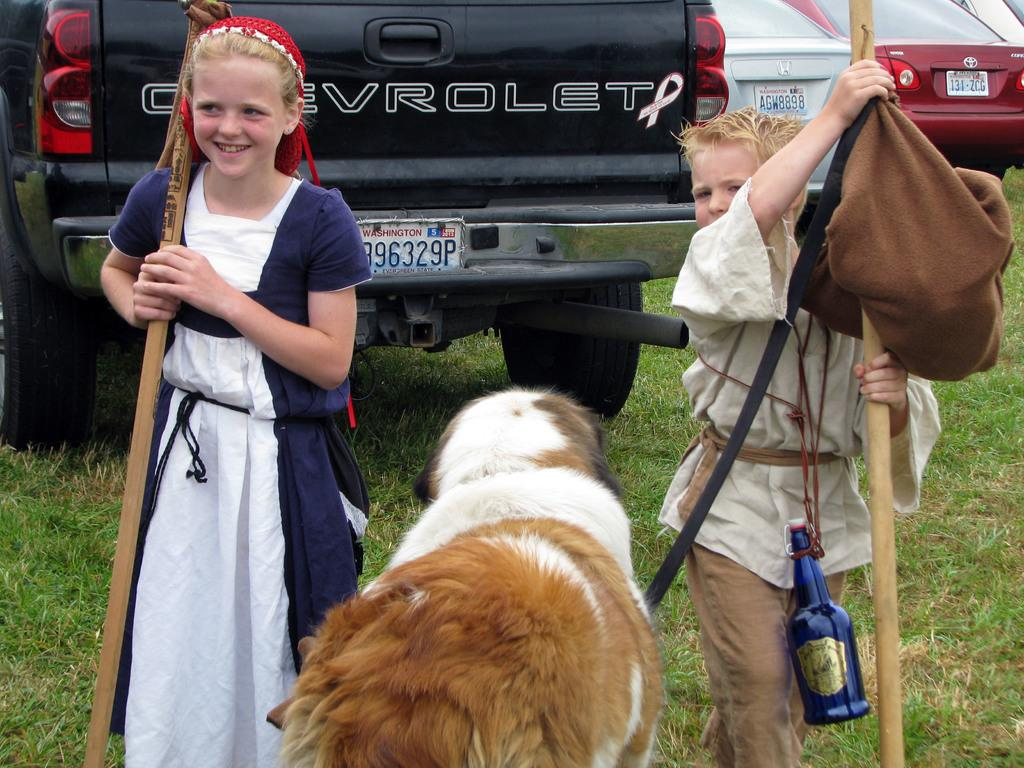How many kids are in the image? There are two kids in the image. What are the kids holding in their hands? The kids are holding sticks in the image. What can be seen on the floor in the image? There is a dog on the floor in the image. What is visible in the background of the image? There are cars on the grass in the background of the image. What type of underwear is the dog wearing in the image? There is no underwear present in the image, and the dog is not wearing any clothing. What form does the market take in the image? There is no market present in the image. 